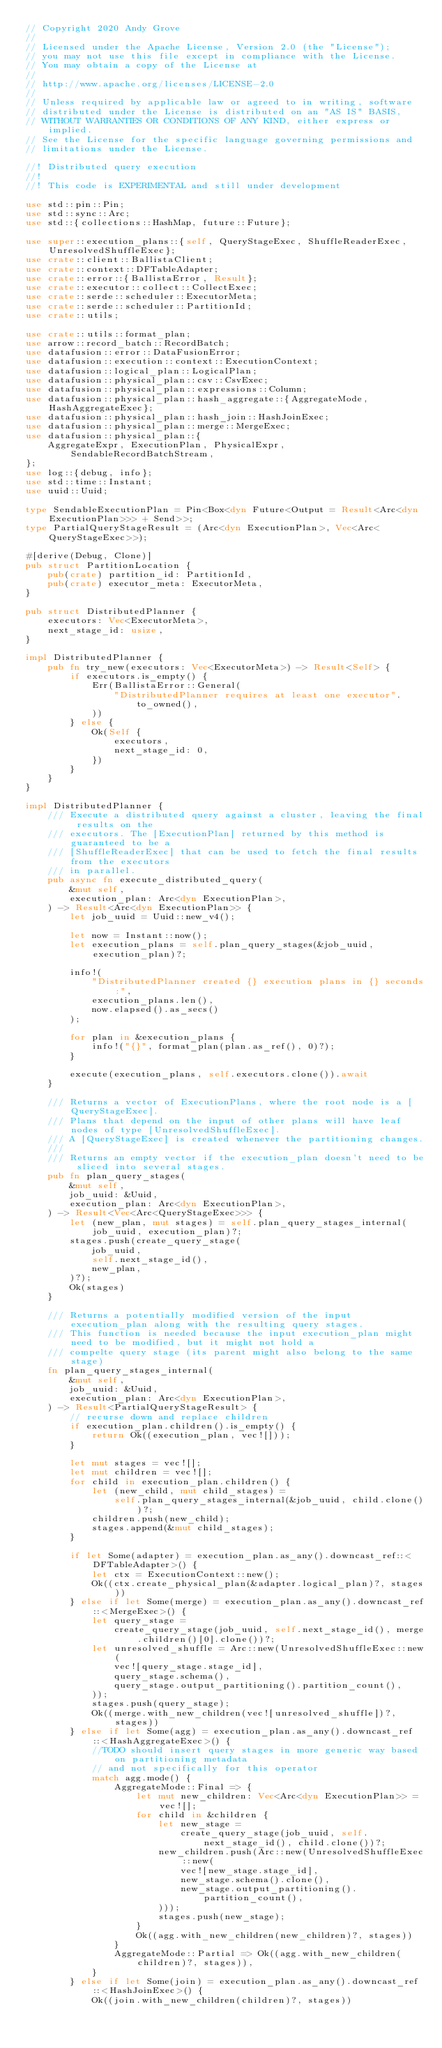<code> <loc_0><loc_0><loc_500><loc_500><_Rust_>// Copyright 2020 Andy Grove
//
// Licensed under the Apache License, Version 2.0 (the "License");
// you may not use this file except in compliance with the License.
// You may obtain a copy of the License at
//
// http://www.apache.org/licenses/LICENSE-2.0
//
// Unless required by applicable law or agreed to in writing, software
// distributed under the License is distributed on an "AS IS" BASIS,
// WITHOUT WARRANTIES OR CONDITIONS OF ANY KIND, either express or implied.
// See the License for the specific language governing permissions and
// limitations under the License.

//! Distributed query execution
//!
//! This code is EXPERIMENTAL and still under development

use std::pin::Pin;
use std::sync::Arc;
use std::{collections::HashMap, future::Future};

use super::execution_plans::{self, QueryStageExec, ShuffleReaderExec, UnresolvedShuffleExec};
use crate::client::BallistaClient;
use crate::context::DFTableAdapter;
use crate::error::{BallistaError, Result};
use crate::executor::collect::CollectExec;
use crate::serde::scheduler::ExecutorMeta;
use crate::serde::scheduler::PartitionId;
use crate::utils;

use crate::utils::format_plan;
use arrow::record_batch::RecordBatch;
use datafusion::error::DataFusionError;
use datafusion::execution::context::ExecutionContext;
use datafusion::logical_plan::LogicalPlan;
use datafusion::physical_plan::csv::CsvExec;
use datafusion::physical_plan::expressions::Column;
use datafusion::physical_plan::hash_aggregate::{AggregateMode, HashAggregateExec};
use datafusion::physical_plan::hash_join::HashJoinExec;
use datafusion::physical_plan::merge::MergeExec;
use datafusion::physical_plan::{
    AggregateExpr, ExecutionPlan, PhysicalExpr, SendableRecordBatchStream,
};
use log::{debug, info};
use std::time::Instant;
use uuid::Uuid;

type SendableExecutionPlan = Pin<Box<dyn Future<Output = Result<Arc<dyn ExecutionPlan>>> + Send>>;
type PartialQueryStageResult = (Arc<dyn ExecutionPlan>, Vec<Arc<QueryStageExec>>);

#[derive(Debug, Clone)]
pub struct PartitionLocation {
    pub(crate) partition_id: PartitionId,
    pub(crate) executor_meta: ExecutorMeta,
}

pub struct DistributedPlanner {
    executors: Vec<ExecutorMeta>,
    next_stage_id: usize,
}

impl DistributedPlanner {
    pub fn try_new(executors: Vec<ExecutorMeta>) -> Result<Self> {
        if executors.is_empty() {
            Err(BallistaError::General(
                "DistributedPlanner requires at least one executor".to_owned(),
            ))
        } else {
            Ok(Self {
                executors,
                next_stage_id: 0,
            })
        }
    }
}

impl DistributedPlanner {
    /// Execute a distributed query against a cluster, leaving the final results on the
    /// executors. The [ExecutionPlan] returned by this method is guaranteed to be a
    /// [ShuffleReaderExec] that can be used to fetch the final results from the executors
    /// in parallel.
    pub async fn execute_distributed_query(
        &mut self,
        execution_plan: Arc<dyn ExecutionPlan>,
    ) -> Result<Arc<dyn ExecutionPlan>> {
        let job_uuid = Uuid::new_v4();

        let now = Instant::now();
        let execution_plans = self.plan_query_stages(&job_uuid, execution_plan)?;

        info!(
            "DistributedPlanner created {} execution plans in {} seconds:",
            execution_plans.len(),
            now.elapsed().as_secs()
        );

        for plan in &execution_plans {
            info!("{}", format_plan(plan.as_ref(), 0)?);
        }

        execute(execution_plans, self.executors.clone()).await
    }

    /// Returns a vector of ExecutionPlans, where the root node is a [QueryStageExec].
    /// Plans that depend on the input of other plans will have leaf nodes of type [UnresolvedShuffleExec].
    /// A [QueryStageExec] is created whenever the partitioning changes.
    ///
    /// Returns an empty vector if the execution_plan doesn't need to be sliced into several stages.
    pub fn plan_query_stages(
        &mut self,
        job_uuid: &Uuid,
        execution_plan: Arc<dyn ExecutionPlan>,
    ) -> Result<Vec<Arc<QueryStageExec>>> {
        let (new_plan, mut stages) = self.plan_query_stages_internal(job_uuid, execution_plan)?;
        stages.push(create_query_stage(
            job_uuid,
            self.next_stage_id(),
            new_plan,
        )?);
        Ok(stages)
    }

    /// Returns a potentially modified version of the input execution_plan along with the resulting query stages.
    /// This function is needed because the input execution_plan might need to be modified, but it might not hold a
    /// compelte query stage (its parent might also belong to the same stage)
    fn plan_query_stages_internal(
        &mut self,
        job_uuid: &Uuid,
        execution_plan: Arc<dyn ExecutionPlan>,
    ) -> Result<PartialQueryStageResult> {
        // recurse down and replace children
        if execution_plan.children().is_empty() {
            return Ok((execution_plan, vec![]));
        }

        let mut stages = vec![];
        let mut children = vec![];
        for child in execution_plan.children() {
            let (new_child, mut child_stages) =
                self.plan_query_stages_internal(&job_uuid, child.clone())?;
            children.push(new_child);
            stages.append(&mut child_stages);
        }

        if let Some(adapter) = execution_plan.as_any().downcast_ref::<DFTableAdapter>() {
            let ctx = ExecutionContext::new();
            Ok((ctx.create_physical_plan(&adapter.logical_plan)?, stages))
        } else if let Some(merge) = execution_plan.as_any().downcast_ref::<MergeExec>() {
            let query_stage =
                create_query_stage(job_uuid, self.next_stage_id(), merge.children()[0].clone())?;
            let unresolved_shuffle = Arc::new(UnresolvedShuffleExec::new(
                vec![query_stage.stage_id],
                query_stage.schema(),
                query_stage.output_partitioning().partition_count(),
            ));
            stages.push(query_stage);
            Ok((merge.with_new_children(vec![unresolved_shuffle])?, stages))
        } else if let Some(agg) = execution_plan.as_any().downcast_ref::<HashAggregateExec>() {
            //TODO should insert query stages in more generic way based on partitioning metadata
            // and not specifically for this operator
            match agg.mode() {
                AggregateMode::Final => {
                    let mut new_children: Vec<Arc<dyn ExecutionPlan>> = vec![];
                    for child in &children {
                        let new_stage =
                            create_query_stage(job_uuid, self.next_stage_id(), child.clone())?;
                        new_children.push(Arc::new(UnresolvedShuffleExec::new(
                            vec![new_stage.stage_id],
                            new_stage.schema().clone(),
                            new_stage.output_partitioning().partition_count(),
                        )));
                        stages.push(new_stage);
                    }
                    Ok((agg.with_new_children(new_children)?, stages))
                }
                AggregateMode::Partial => Ok((agg.with_new_children(children)?, stages)),
            }
        } else if let Some(join) = execution_plan.as_any().downcast_ref::<HashJoinExec>() {
            Ok((join.with_new_children(children)?, stages))</code> 